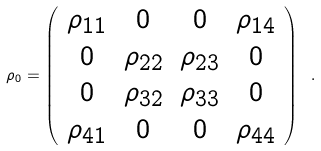<formula> <loc_0><loc_0><loc_500><loc_500>\rho _ { 0 } = \left ( \begin{array} { c c c c } \rho _ { 1 1 } & 0 & 0 & \rho _ { 1 4 } \\ 0 & \rho _ { 2 2 } & \rho _ { 2 3 } & 0 \\ 0 & \rho _ { 3 2 } & \rho _ { 3 3 } & 0 \\ \rho _ { 4 1 } & 0 & 0 & \rho _ { 4 4 } \end{array} \right ) \ .</formula> 